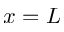Convert formula to latex. <formula><loc_0><loc_0><loc_500><loc_500>x = L</formula> 